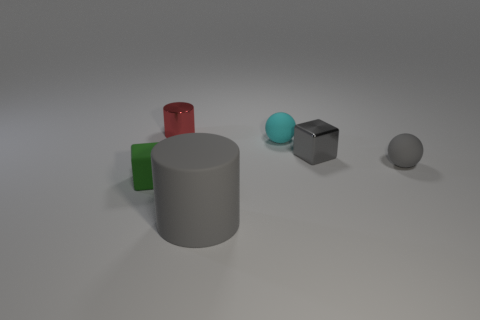What is the size of the gray rubber thing that is the same shape as the tiny cyan object?
Make the answer very short. Small. Do the gray matte thing to the right of the matte cylinder and the cyan rubber object have the same shape?
Keep it short and to the point. Yes. There is a large gray matte thing; what shape is it?
Your answer should be very brief. Cylinder. What material is the ball behind the small block that is to the right of the gray thing that is in front of the tiny green cube made of?
Your answer should be compact. Rubber. There is a block that is the same color as the large thing; what material is it?
Give a very brief answer. Metal. How many things are either purple things or metallic objects?
Provide a short and direct response. 2. Does the cube right of the tiny red metallic cylinder have the same material as the small cyan object?
Your answer should be compact. No. What number of objects are either tiny things that are on the left side of the large cylinder or gray matte cylinders?
Offer a terse response. 3. There is a tiny block that is the same material as the tiny gray ball; what is its color?
Make the answer very short. Green. Is there a red cylinder that has the same size as the gray matte ball?
Offer a terse response. Yes. 